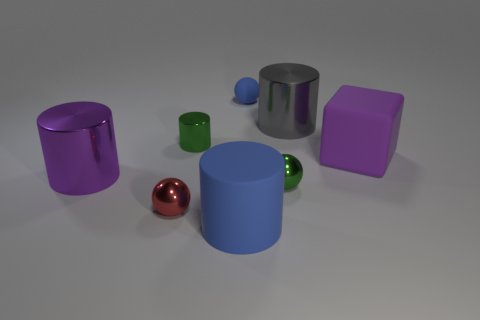There is a cube; is it the same size as the metallic cylinder that is left of the small cylinder?
Provide a succinct answer. Yes. There is a object that is the same color as the rubber cube; what is its material?
Ensure brevity in your answer.  Metal. There is a object behind the big shiny object that is behind the big object that is on the left side of the large blue thing; what is its size?
Offer a terse response. Small. Is the number of rubber cylinders that are behind the purple cylinder greater than the number of small blue matte balls on the left side of the tiny rubber sphere?
Offer a terse response. No. How many small green shiny cylinders are in front of the large purple object that is on the right side of the big gray metallic cylinder?
Give a very brief answer. 0. Are there any small things that have the same color as the tiny metal cylinder?
Ensure brevity in your answer.  Yes. Do the red metal ball and the blue matte ball have the same size?
Your response must be concise. Yes. Is the color of the small matte object the same as the small shiny cylinder?
Your answer should be very brief. No. There is a large object that is right of the shiny cylinder on the right side of the rubber sphere; what is its material?
Provide a short and direct response. Rubber. There is a small green object that is the same shape as the tiny blue object; what material is it?
Offer a very short reply. Metal. 